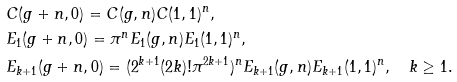Convert formula to latex. <formula><loc_0><loc_0><loc_500><loc_500>& C ( g + n , 0 ) = C ( g , n ) C ( 1 , 1 ) ^ { n } , \\ & E _ { 1 } ( g + n , 0 ) = \pi ^ { n } E _ { 1 } ( g , n ) E _ { 1 } ( 1 , 1 ) ^ { n } , \\ & E _ { k + 1 } ( g + n , 0 ) = ( 2 ^ { k + 1 } ( 2 k ) ! \pi ^ { 2 k + 1 } ) ^ { n } E _ { k + 1 } ( g , n ) E _ { k + 1 } ( 1 , 1 ) ^ { n } , \quad k \geq 1 .</formula> 